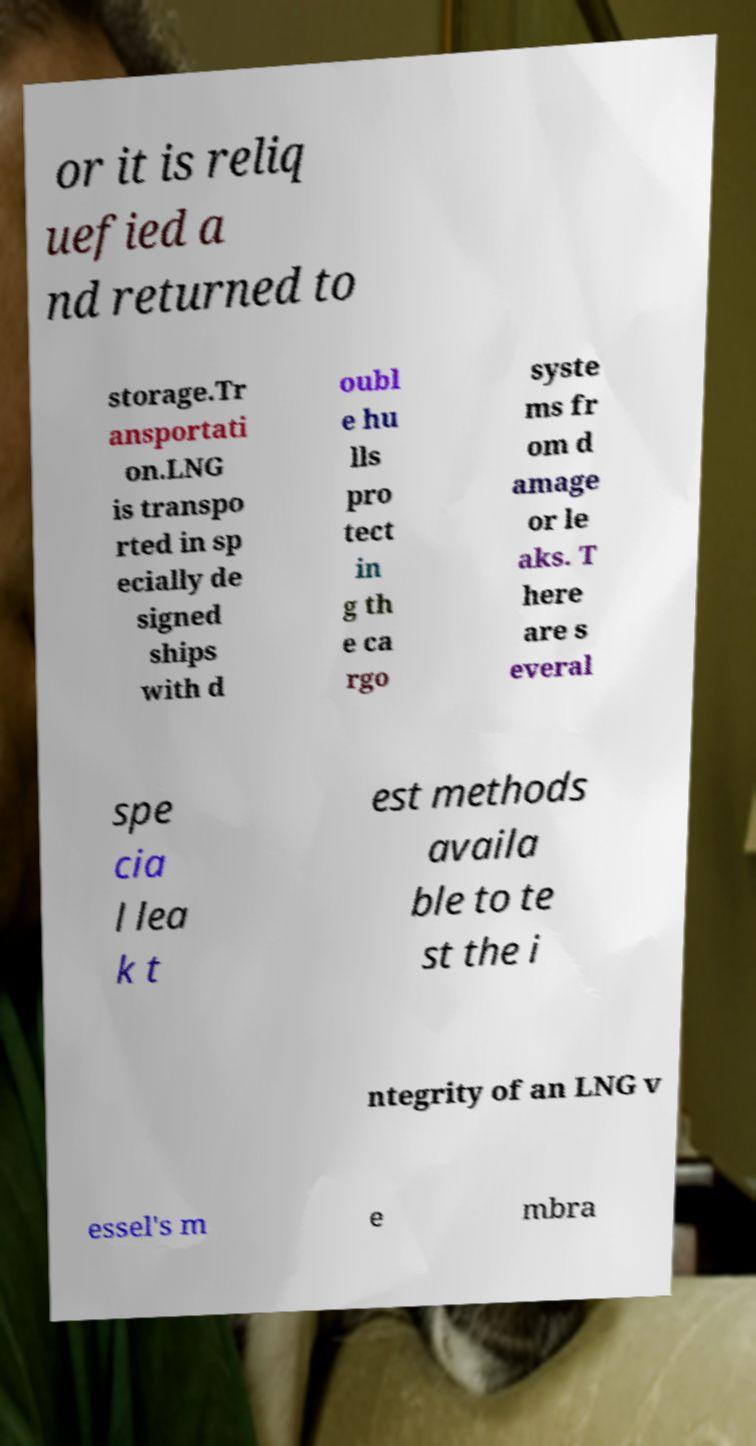What messages or text are displayed in this image? I need them in a readable, typed format. or it is reliq uefied a nd returned to storage.Tr ansportati on.LNG is transpo rted in sp ecially de signed ships with d oubl e hu lls pro tect in g th e ca rgo syste ms fr om d amage or le aks. T here are s everal spe cia l lea k t est methods availa ble to te st the i ntegrity of an LNG v essel's m e mbra 